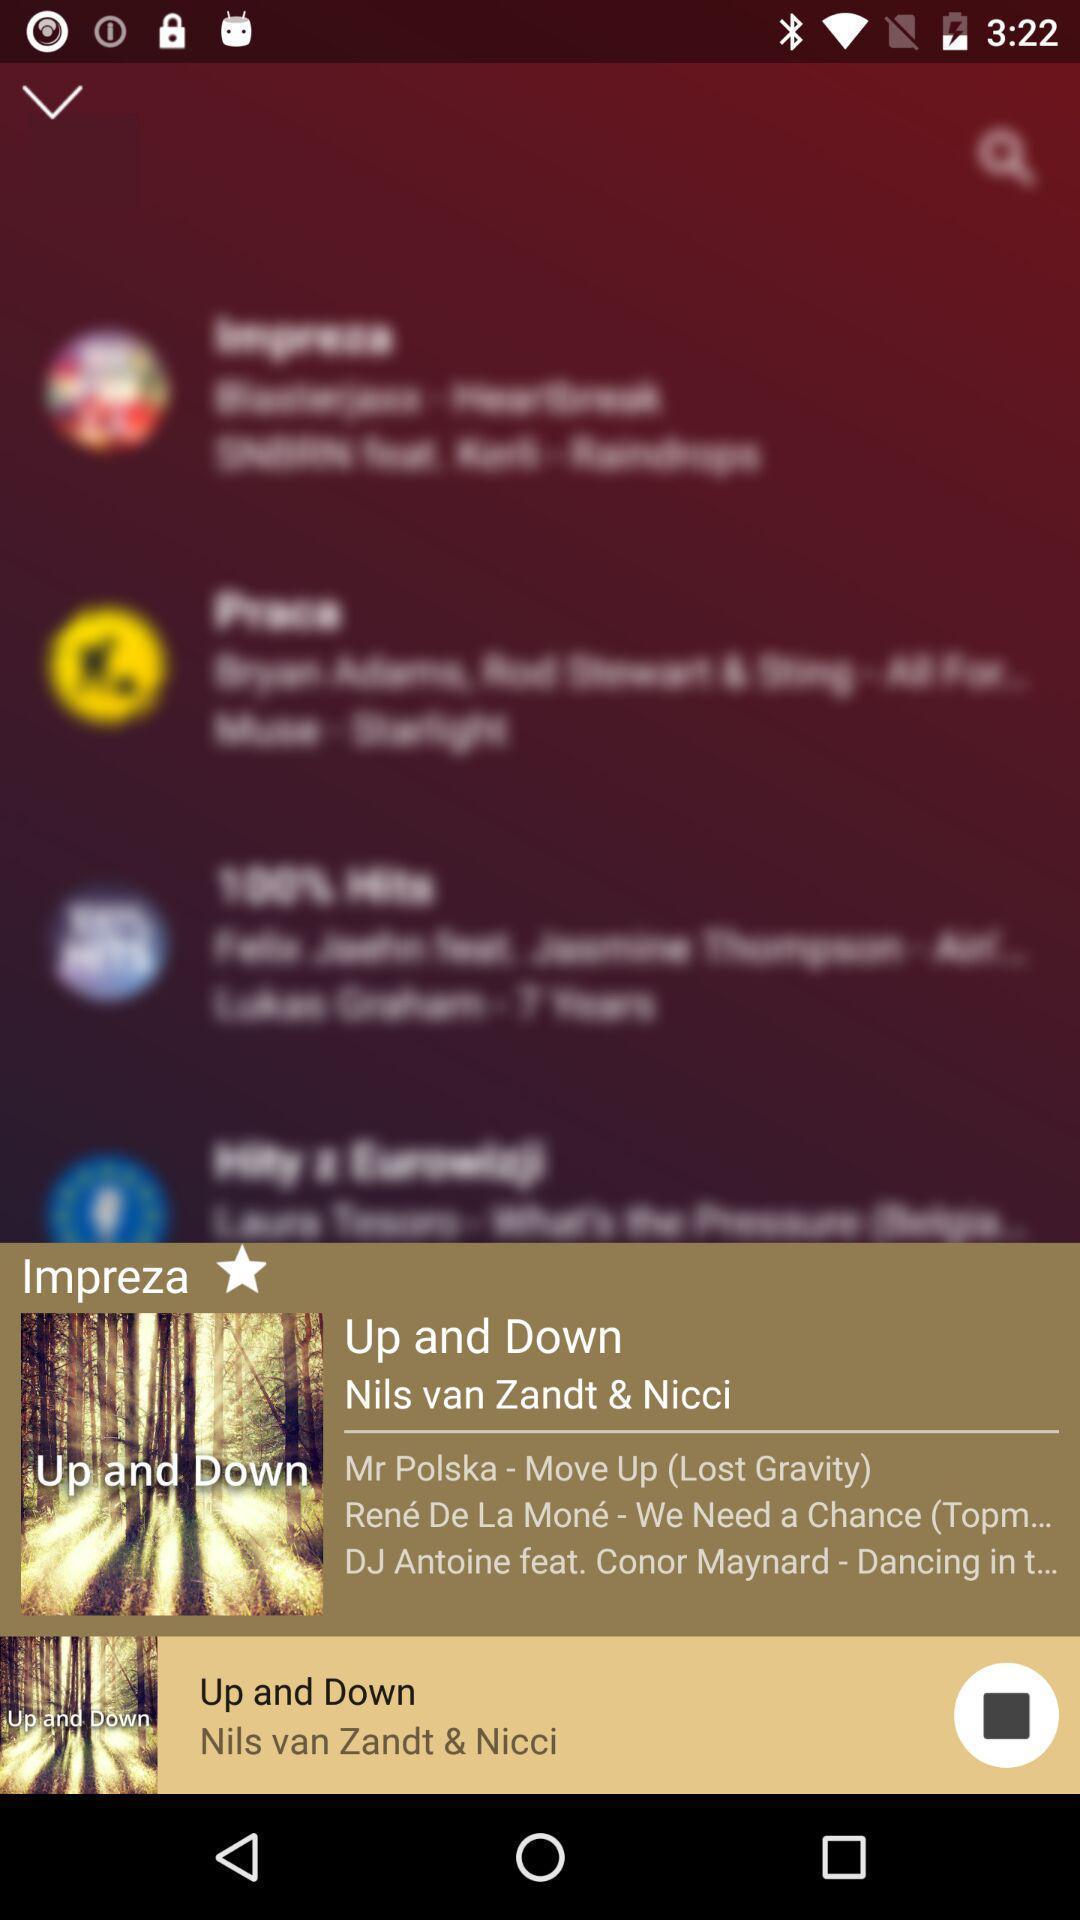Describe the visual elements of this screenshot. Popup displaying a song in a music app. 